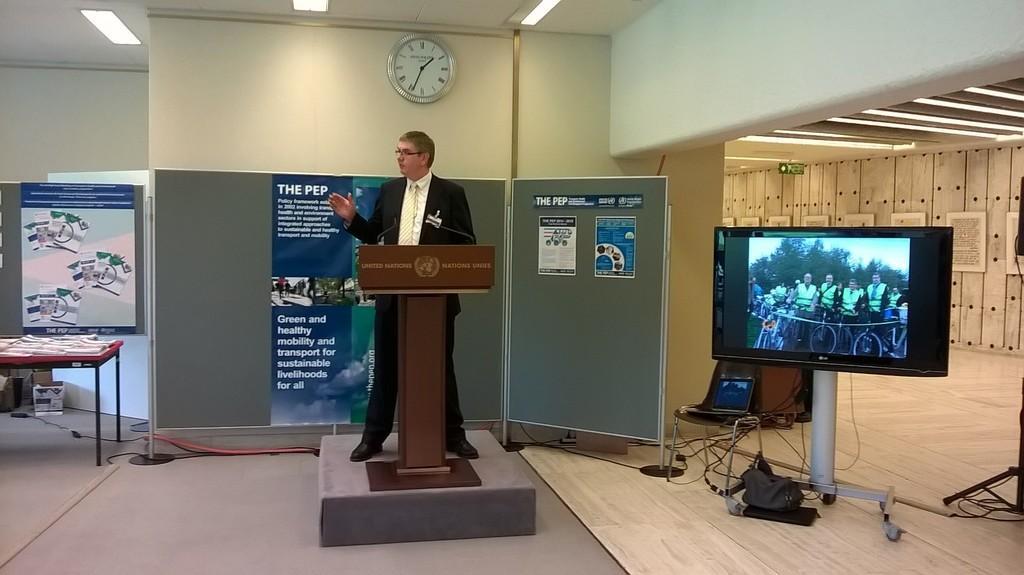Can you describe this image briefly? In this image a person is standing behind the podium having a mike on it. Behind him there is a board having few posts attached to it. Left side there is a table having few objects on it. Right side there is a screen on the stand. Beside there is a chair having a laptop on it. Few objects are on the floor. A clock is attached to the wall. Top of the image few lights are attached to the roof. Right side few frames are attached to the wall. 